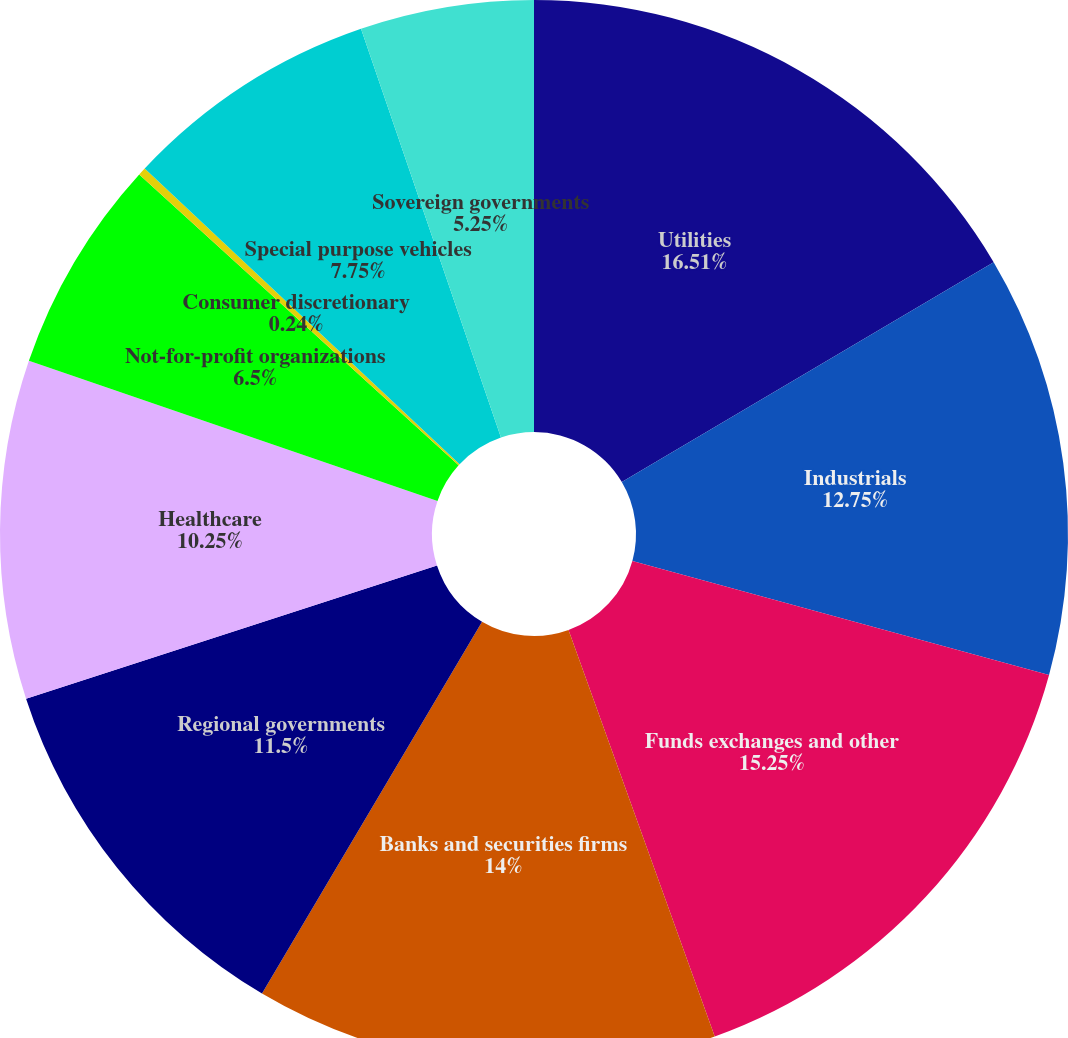<chart> <loc_0><loc_0><loc_500><loc_500><pie_chart><fcel>Utilities<fcel>Industrials<fcel>Funds exchanges and other<fcel>Banks and securities firms<fcel>Regional governments<fcel>Healthcare<fcel>Not-for-profit organizations<fcel>Consumer discretionary<fcel>Special purpose vehicles<fcel>Sovereign governments<nl><fcel>16.5%<fcel>12.75%<fcel>15.25%<fcel>14.0%<fcel>11.5%<fcel>10.25%<fcel>6.5%<fcel>0.24%<fcel>7.75%<fcel>5.25%<nl></chart> 